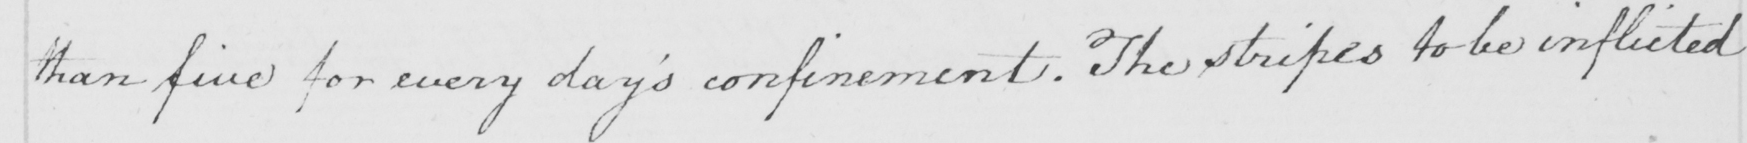Can you read and transcribe this handwriting? than five for every day ' s confinement . The stripes to be inflicted 